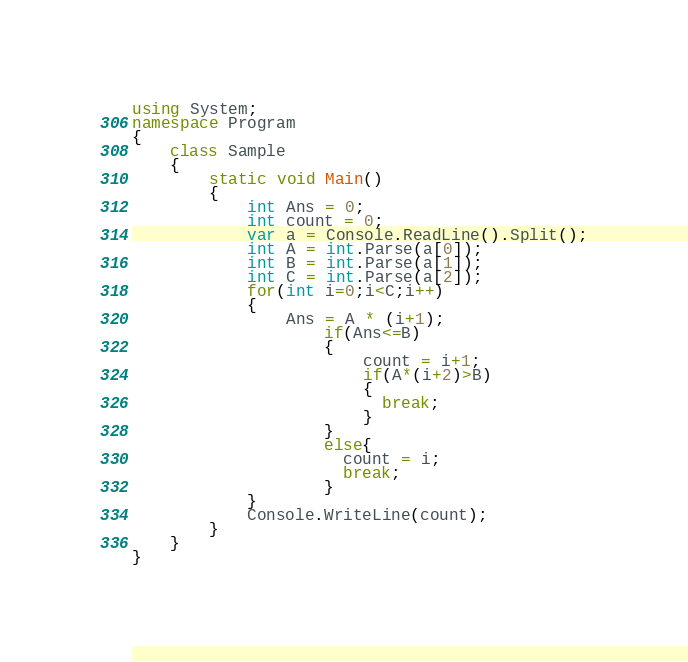<code> <loc_0><loc_0><loc_500><loc_500><_C#_>using System;
namespace Program
{
	class Sample
    {
    	static void Main()
        {
          	int Ans = 0;
            int count = 0;
        	var a = Console.ReadLine().Split();
          	int A = int.Parse(a[0]);
          	int B = int.Parse(a[1]);
          	int C = int.Parse(a[2]);
          	for(int i=0;i<C;i++)
            {
            	Ans = A * (i+1);
              		if(Ans<=B)
                    {
          	        	count = i+1;
                      	if(A*(i+2)>B)
                        {
                          break;
                        }
                    }
                    else{ 
                      count = i;
                      break;
                    }
            }
          	Console.WriteLine(count);
        }
    }
}</code> 